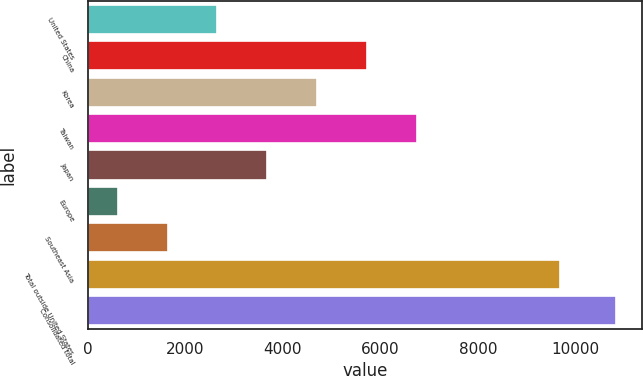Convert chart to OTSL. <chart><loc_0><loc_0><loc_500><loc_500><bar_chart><fcel>United States<fcel>China<fcel>Korea<fcel>Taiwan<fcel>Japan<fcel>Europe<fcel>Southeast Asia<fcel>Total outside United States<fcel>Consolidated total<nl><fcel>2657<fcel>5720<fcel>4699<fcel>6741<fcel>3678<fcel>615<fcel>1636<fcel>9682<fcel>10825<nl></chart> 